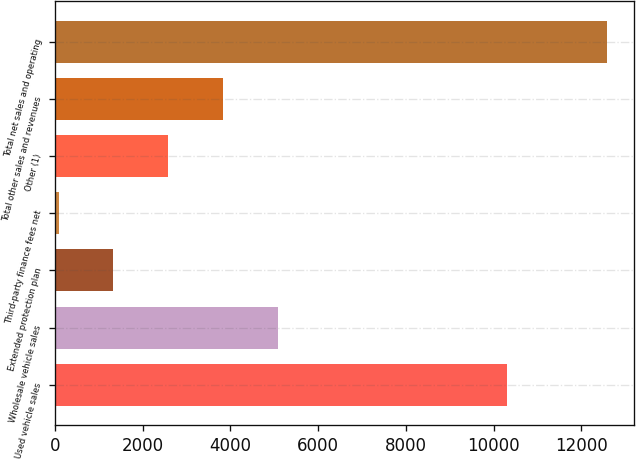Convert chart. <chart><loc_0><loc_0><loc_500><loc_500><bar_chart><fcel>Used vehicle sales<fcel>Wholesale vehicle sales<fcel>Extended protection plan<fcel>Third-party finance fees net<fcel>Other (1)<fcel>Total other sales and revenues<fcel>Total net sales and operating<nl><fcel>10306.3<fcel>5079.4<fcel>1331.95<fcel>82.8<fcel>2581.1<fcel>3830.25<fcel>12574.3<nl></chart> 